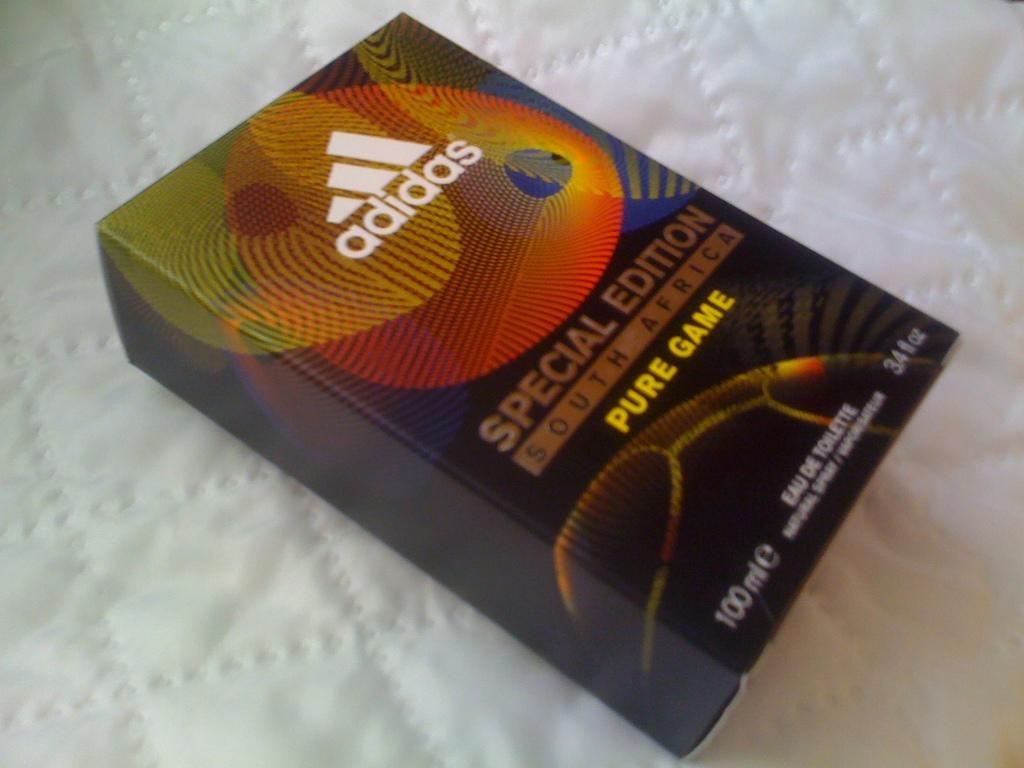What is in the box?
Keep it short and to the point. Eau de toilette. How many ml does the product contain?
Give a very brief answer. 100. 